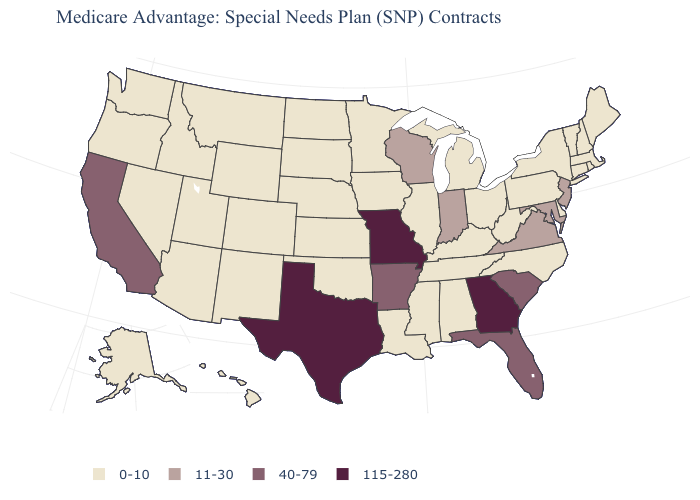What is the value of North Dakota?
Give a very brief answer. 0-10. Is the legend a continuous bar?
Keep it brief. No. What is the lowest value in states that border South Dakota?
Concise answer only. 0-10. What is the value of Arkansas?
Write a very short answer. 40-79. Name the states that have a value in the range 115-280?
Keep it brief. Georgia, Missouri, Texas. Does Kentucky have the highest value in the South?
Be succinct. No. Name the states that have a value in the range 40-79?
Give a very brief answer. Arkansas, California, Florida, South Carolina. Name the states that have a value in the range 0-10?
Write a very short answer. Alaska, Alabama, Arizona, Colorado, Connecticut, Delaware, Hawaii, Iowa, Idaho, Illinois, Kansas, Kentucky, Louisiana, Massachusetts, Maine, Michigan, Minnesota, Mississippi, Montana, North Carolina, North Dakota, Nebraska, New Hampshire, New Mexico, Nevada, New York, Ohio, Oklahoma, Oregon, Pennsylvania, Rhode Island, South Dakota, Tennessee, Utah, Vermont, Washington, West Virginia, Wyoming. What is the lowest value in the USA?
Write a very short answer. 0-10. Among the states that border Idaho , which have the highest value?
Concise answer only. Montana, Nevada, Oregon, Utah, Washington, Wyoming. Does Virginia have a higher value than California?
Be succinct. No. What is the lowest value in states that border Michigan?
Short answer required. 0-10. Does Alaska have a lower value than New York?
Write a very short answer. No. Name the states that have a value in the range 115-280?
Be succinct. Georgia, Missouri, Texas. 